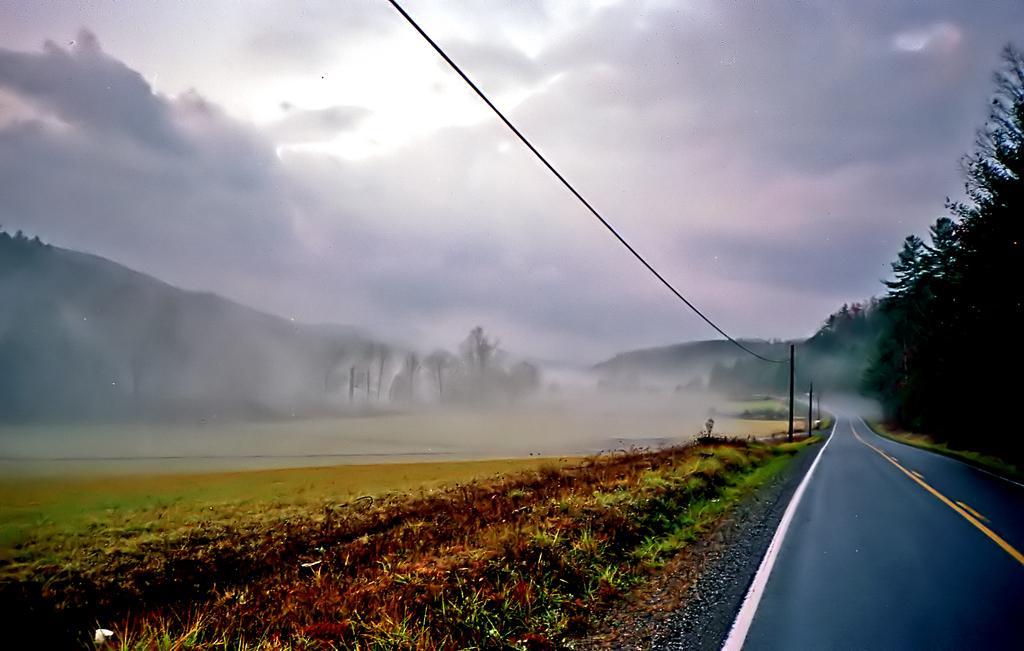Please provide a concise description of this image. In this image I see the road on which there are white and yellow lines and I see the poles and I see a wire over here and I see the plants. In the background I see the trees and I see the fog and I see the cloudy sky. 